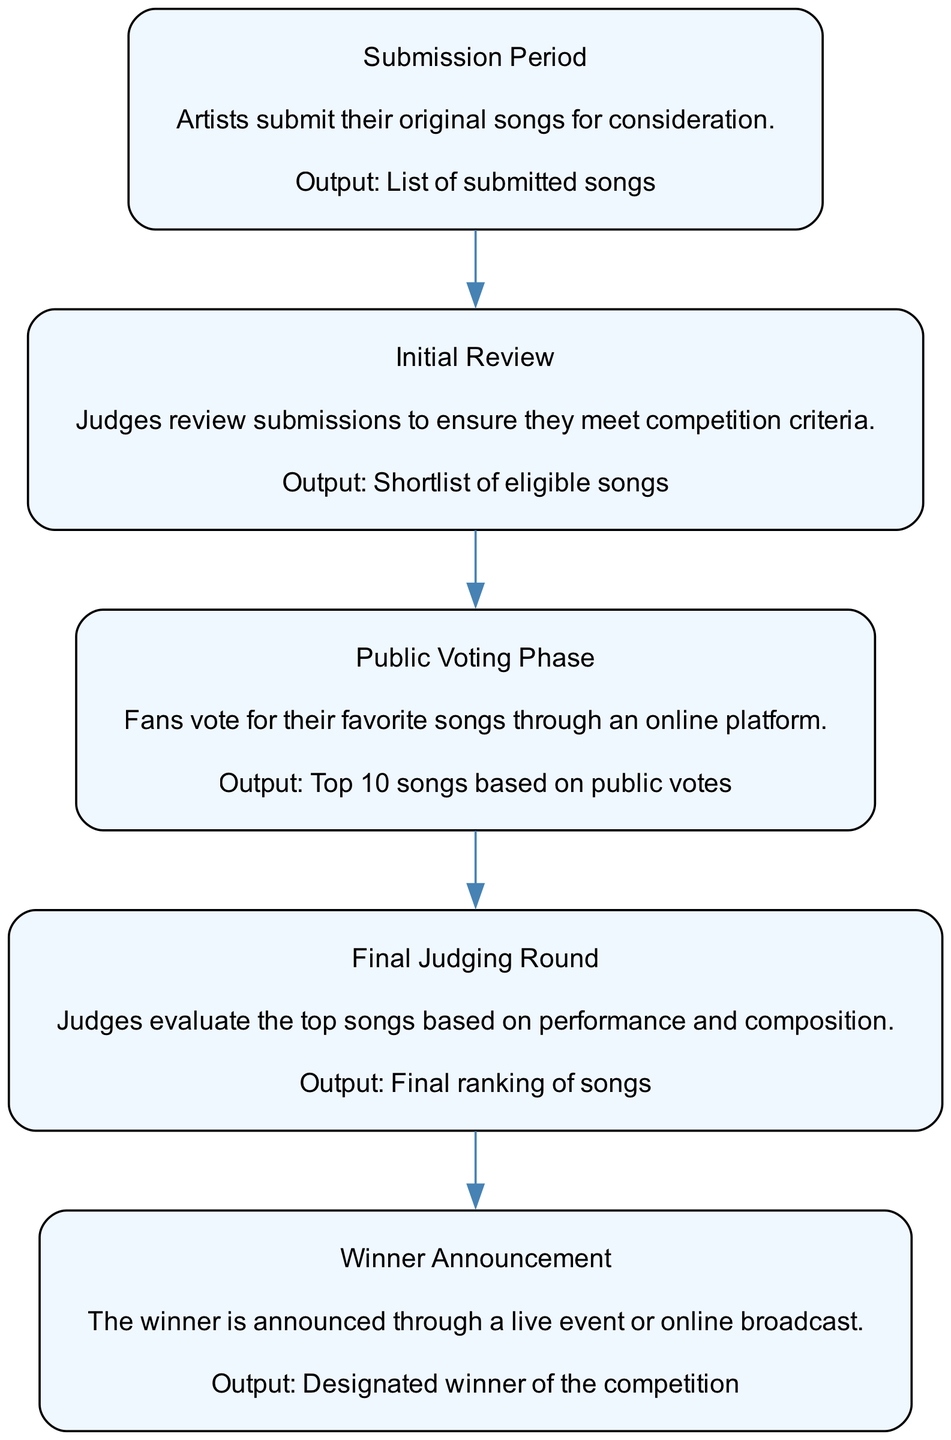What is the first step in the competition process? The first step, as indicated in the diagram, is "Submission Period," where artists submit their original songs.
Answer: Submission Period How many total steps are shown in the diagram? By counting each of the steps listed in the diagram, there are a total of 5 steps present.
Answer: 5 What is the output of the Initial Review step? According to the flow chart, the Initial Review outputs a "Shortlist of eligible songs" after judges review their submissions.
Answer: Shortlist of eligible songs Which step comes after the Public Voting Phase? The flow chart shows that the step following the Public Voting Phase is the "Final Judging Round" where judges evaluate the top songs.
Answer: Final Judging Round What kind of event is used to announce the winner? The diagram states that the winner is announced through a "live event or online broadcast," indicating the mode of announcement for the winner.
Answer: live event or online broadcast What are the judges' criteria in the Final Judging Round? In the Final Judging Round, judges evaluate the top songs based on two key factors: performance and composition, as highlighted in the description.
Answer: performance and composition What is the last step in the song competition process? The last step noted in the diagram is the "Winner Announcement," which signifies the conclusion of the competition by declaring the winner.
Answer: Winner Announcement What happens during the Public Voting Phase? During the Public Voting Phase, fans vote for their favorite songs through an online platform, which is specified as the activity taking place in this step.
Answer: Fans vote for their favorite songs What connects the Initial Review to the Public Voting Phase? The flow chart indicates a direct sequential connection, where the output of the Initial Review leads into the Public Voting Phase, establishing a clear flow from one step to the next.
Answer: Initial Review to Public Voting Phase 